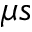Convert formula to latex. <formula><loc_0><loc_0><loc_500><loc_500>\mu s</formula> 